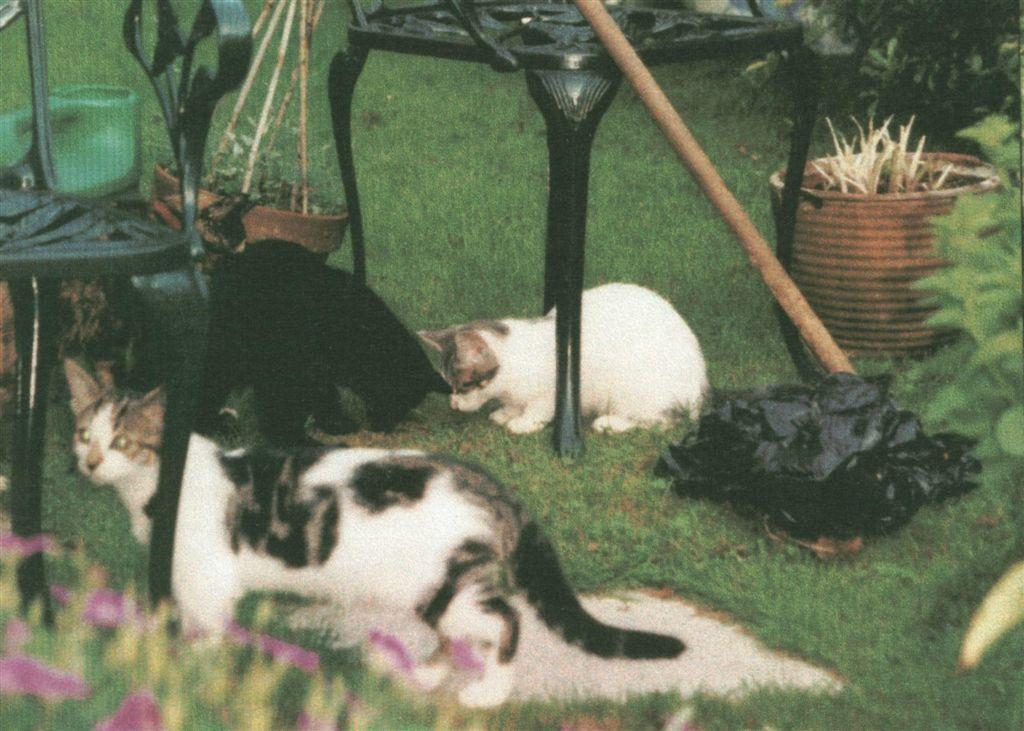What animals can be seen on the grassland in the image? There are cats on the grassland in the center of the image. What type of furniture is present in the image? There are chairs in the image. What type of vegetation is visible in the image? There are plants in the image. What object is used for holding a plant in the image? There is a plant pot in the image. Where is the spot where the town is located in the image? There is no town present in the image. What type of jelly can be seen on the chairs in the image? There is no jelly present on the chairs or anywhere else in the image. 